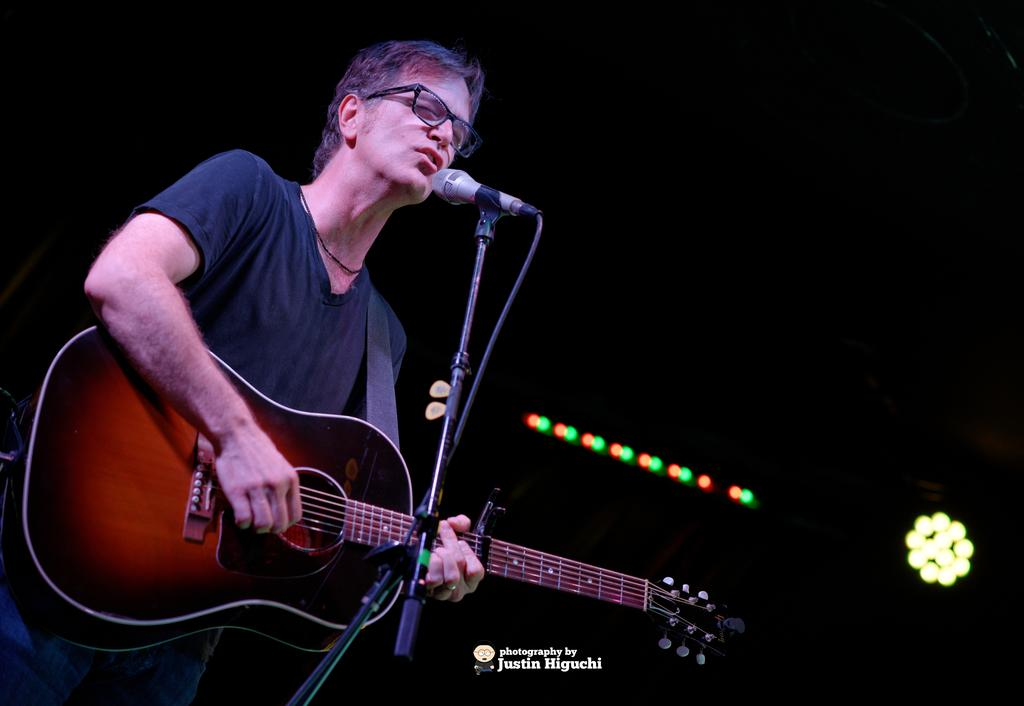What is the main subject of the image? The main subject of the image is a guy. What is the guy doing in the image? The guy is singing and playing a guitar. What is the guy holding in the image? The guy is holding a microphone. What can be seen in the background of the image? There are lights in the background of the image. How does the crowd react to the guy's performance in the image? There is no crowd present in the image, so it is not possible to determine their reaction. 